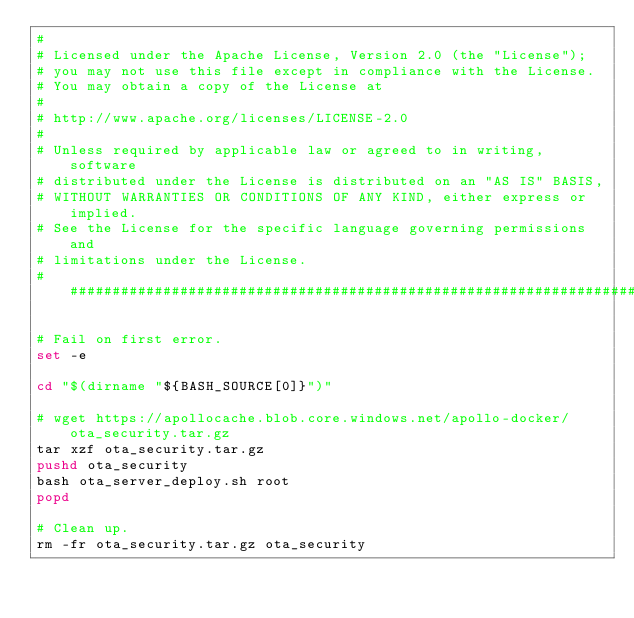Convert code to text. <code><loc_0><loc_0><loc_500><loc_500><_Bash_>#
# Licensed under the Apache License, Version 2.0 (the "License");
# you may not use this file except in compliance with the License.
# You may obtain a copy of the License at
#
# http://www.apache.org/licenses/LICENSE-2.0
#
# Unless required by applicable law or agreed to in writing, software
# distributed under the License is distributed on an "AS IS" BASIS,
# WITHOUT WARRANTIES OR CONDITIONS OF ANY KIND, either express or implied.
# See the License for the specific language governing permissions and
# limitations under the License.
###############################################################################

# Fail on first error.
set -e

cd "$(dirname "${BASH_SOURCE[0]}")"

# wget https://apollocache.blob.core.windows.net/apollo-docker/ota_security.tar.gz
tar xzf ota_security.tar.gz
pushd ota_security
bash ota_server_deploy.sh root
popd

# Clean up.
rm -fr ota_security.tar.gz ota_security
</code> 